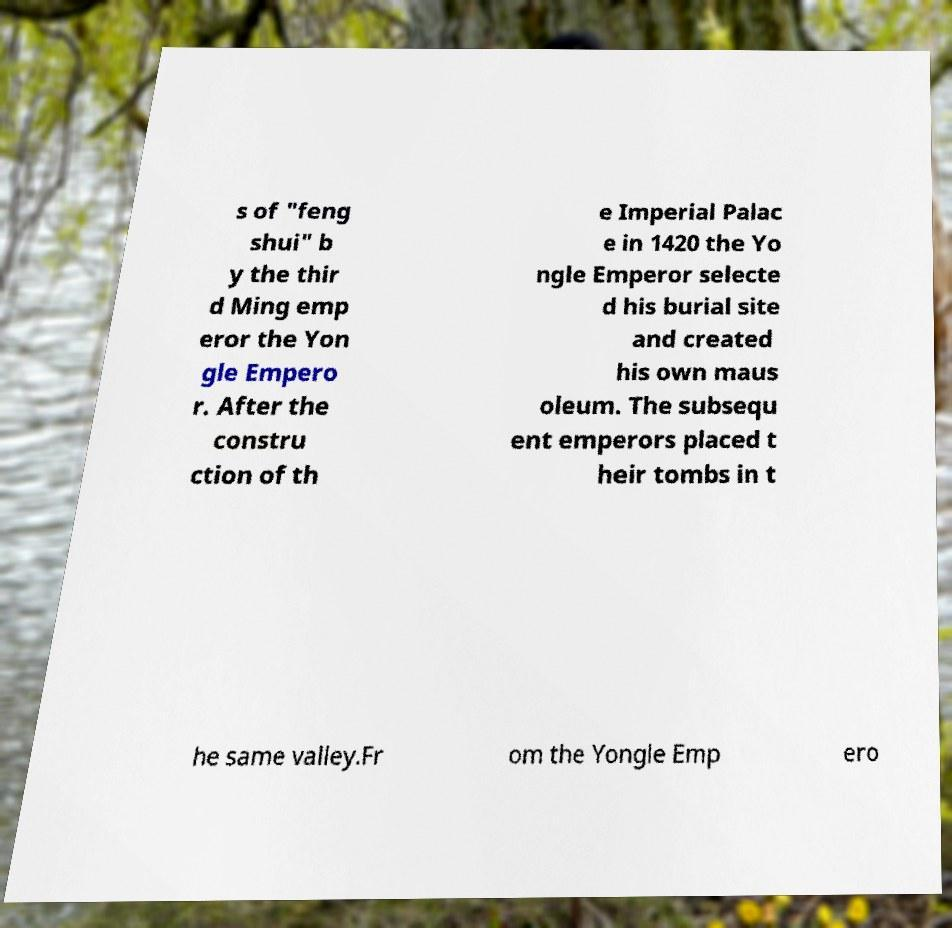What messages or text are displayed in this image? I need them in a readable, typed format. s of "feng shui" b y the thir d Ming emp eror the Yon gle Empero r. After the constru ction of th e Imperial Palac e in 1420 the Yo ngle Emperor selecte d his burial site and created his own maus oleum. The subsequ ent emperors placed t heir tombs in t he same valley.Fr om the Yongle Emp ero 